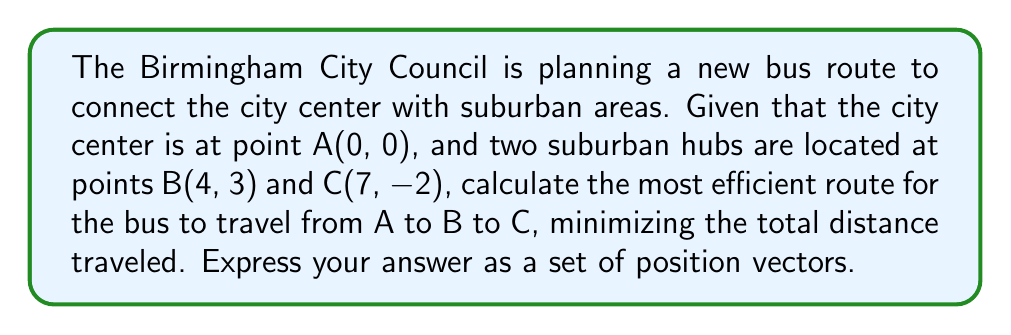Give your solution to this math problem. To solve this problem, we'll use vector geometry to find the most efficient route. Let's approach this step-by-step:

1. First, let's define our vectors:
   $\vec{AB} = (4, 3)$
   $\vec{AC} = (7, -2)$

2. The most efficient route will be the direct path from A to B, then from B to C. We need to find $\vec{BC}$.

3. To find $\vec{BC}$, we can subtract $\vec{AB}$ from $\vec{AC}$:
   $\vec{BC} = \vec{AC} - \vec{AB} = (7, -2) - (4, 3) = (3, -5)$

4. Now we have our route defined by two vectors:
   A to B: $\vec{AB} = (4, 3)$
   B to C: $\vec{BC} = (3, -5)$

5. To express this as position vectors, we need to give the position of each point relative to the origin (A):
   A: $(0, 0)$
   B: $\vec{AB} = (4, 3)$
   C: $\vec{AC} = \vec{AB} + \vec{BC} = (4, 3) + (3, -5) = (7, -2)$

6. The most efficient route is represented by these position vectors in order.

[asy]
unitsize(1cm);
dot((0,0));
dot((4,3));
dot((7,-2));
draw((0,0)--(4,3)--(7,-2), arrow=Arrow(TeXHead));
label("A(0,0)", (0,0), SW);
label("B(4,3)", (4,3), NE);
label("C(7,-2)", (7,-2), SE);
label("$\vec{AB}$", (2,1.5), NW);
label("$\vec{BC}$", (5.5,0.5), SE);
[/asy]
Answer: $\{(0, 0), (4, 3), (7, -2)\}$ 